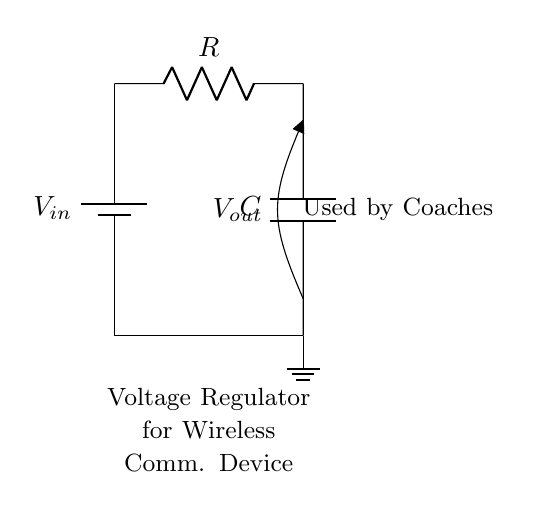What is the input voltage in this circuit? The input voltage is labeled as V sub in (Vₐₗₑ), which is the voltage supplied to the circuit.
Answer: V sub in What does the capacitor represent in this circuit? The capacitor is indicated by the symbol labeled C, and in a voltage regulator, it stores energy and helps smooth out voltage fluctuations.
Answer: C What is the main function of the resistor in this circuit? The resistor, labeled R, restricts current flow and is an essential part of the voltage regulating action when combined with the capacitor.
Answer: R What type of circuit is shown in the diagram? The circuit is a voltage regulator circuit for wireless communication devices, which is particularly useful for maintaining stable voltage levels.
Answer: Voltage regulator How are the capacitor and resistor positioned in relation to each other? The capacitor is positioned vertically down from the output voltage node and is connected to the bottom side of the resistor at the output.
Answer: The output is connected to both What is the significance of the ground in this diagram? The ground serves as a reference point in the circuit, providing a common return path for current and ensuring voltage stability in the circuit.
Answer: Reference point What is the output voltage in this circuit? The output voltage is marked as V sub out (Vₒₑₑ), indicating the voltage available across the capacitor after the regulation process.
Answer: V sub out 